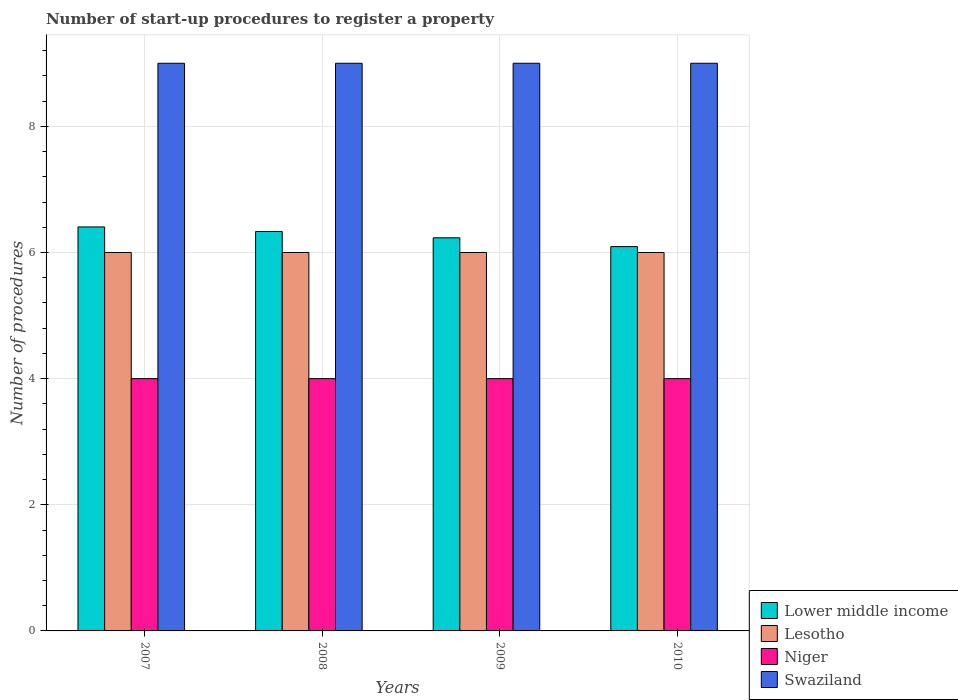How many different coloured bars are there?
Give a very brief answer. 4. Are the number of bars per tick equal to the number of legend labels?
Offer a very short reply. Yes. How many bars are there on the 1st tick from the right?
Offer a very short reply. 4. What is the label of the 2nd group of bars from the left?
Provide a short and direct response. 2008. Across all years, what is the maximum number of procedures required to register a property in Niger?
Make the answer very short. 4. Across all years, what is the minimum number of procedures required to register a property in Lesotho?
Provide a succinct answer. 6. In which year was the number of procedures required to register a property in Lower middle income maximum?
Provide a short and direct response. 2007. In which year was the number of procedures required to register a property in Niger minimum?
Your answer should be very brief. 2007. What is the total number of procedures required to register a property in Lower middle income in the graph?
Make the answer very short. 25.06. What is the difference between the number of procedures required to register a property in Lower middle income in 2008 and that in 2010?
Make the answer very short. 0.24. What is the difference between the number of procedures required to register a property in Niger in 2008 and the number of procedures required to register a property in Lower middle income in 2007?
Ensure brevity in your answer.  -2.4. What is the ratio of the number of procedures required to register a property in Lesotho in 2007 to that in 2008?
Keep it short and to the point. 1. Is the difference between the number of procedures required to register a property in Swaziland in 2008 and 2009 greater than the difference between the number of procedures required to register a property in Niger in 2008 and 2009?
Make the answer very short. No. What is the difference between the highest and the second highest number of procedures required to register a property in Lower middle income?
Offer a very short reply. 0.07. What is the difference between the highest and the lowest number of procedures required to register a property in Swaziland?
Offer a terse response. 0. In how many years, is the number of procedures required to register a property in Lesotho greater than the average number of procedures required to register a property in Lesotho taken over all years?
Offer a terse response. 0. Is it the case that in every year, the sum of the number of procedures required to register a property in Lower middle income and number of procedures required to register a property in Niger is greater than the sum of number of procedures required to register a property in Swaziland and number of procedures required to register a property in Lesotho?
Offer a terse response. Yes. What does the 4th bar from the left in 2009 represents?
Make the answer very short. Swaziland. What does the 3rd bar from the right in 2009 represents?
Your answer should be compact. Lesotho. How many bars are there?
Offer a very short reply. 16. Are the values on the major ticks of Y-axis written in scientific E-notation?
Your response must be concise. No. Where does the legend appear in the graph?
Your response must be concise. Bottom right. How are the legend labels stacked?
Your answer should be compact. Vertical. What is the title of the graph?
Your answer should be compact. Number of start-up procedures to register a property. What is the label or title of the X-axis?
Make the answer very short. Years. What is the label or title of the Y-axis?
Your answer should be compact. Number of procedures. What is the Number of procedures of Lower middle income in 2007?
Your response must be concise. 6.4. What is the Number of procedures in Lesotho in 2007?
Offer a very short reply. 6. What is the Number of procedures in Lower middle income in 2008?
Ensure brevity in your answer.  6.33. What is the Number of procedures in Niger in 2008?
Offer a terse response. 4. What is the Number of procedures of Swaziland in 2008?
Offer a very short reply. 9. What is the Number of procedures in Lower middle income in 2009?
Provide a succinct answer. 6.23. What is the Number of procedures of Niger in 2009?
Give a very brief answer. 4. What is the Number of procedures of Lower middle income in 2010?
Make the answer very short. 6.09. What is the Number of procedures of Niger in 2010?
Your answer should be very brief. 4. What is the Number of procedures of Swaziland in 2010?
Keep it short and to the point. 9. Across all years, what is the maximum Number of procedures of Lower middle income?
Your answer should be very brief. 6.4. Across all years, what is the maximum Number of procedures in Lesotho?
Keep it short and to the point. 6. Across all years, what is the minimum Number of procedures of Lower middle income?
Make the answer very short. 6.09. Across all years, what is the minimum Number of procedures in Lesotho?
Make the answer very short. 6. Across all years, what is the minimum Number of procedures of Niger?
Your answer should be compact. 4. What is the total Number of procedures of Lower middle income in the graph?
Your response must be concise. 25.06. What is the total Number of procedures in Lesotho in the graph?
Your answer should be compact. 24. What is the total Number of procedures of Niger in the graph?
Offer a very short reply. 16. What is the total Number of procedures of Swaziland in the graph?
Provide a short and direct response. 36. What is the difference between the Number of procedures of Lower middle income in 2007 and that in 2008?
Offer a very short reply. 0.07. What is the difference between the Number of procedures in Lesotho in 2007 and that in 2008?
Keep it short and to the point. 0. What is the difference between the Number of procedures in Swaziland in 2007 and that in 2008?
Offer a terse response. 0. What is the difference between the Number of procedures of Lower middle income in 2007 and that in 2009?
Provide a short and direct response. 0.17. What is the difference between the Number of procedures of Lower middle income in 2007 and that in 2010?
Offer a very short reply. 0.31. What is the difference between the Number of procedures in Lesotho in 2007 and that in 2010?
Provide a short and direct response. 0. What is the difference between the Number of procedures of Swaziland in 2007 and that in 2010?
Give a very brief answer. 0. What is the difference between the Number of procedures of Lower middle income in 2008 and that in 2009?
Offer a very short reply. 0.1. What is the difference between the Number of procedures of Lesotho in 2008 and that in 2009?
Keep it short and to the point. 0. What is the difference between the Number of procedures of Niger in 2008 and that in 2009?
Ensure brevity in your answer.  0. What is the difference between the Number of procedures in Lower middle income in 2008 and that in 2010?
Your response must be concise. 0.24. What is the difference between the Number of procedures of Lesotho in 2008 and that in 2010?
Give a very brief answer. 0. What is the difference between the Number of procedures in Niger in 2008 and that in 2010?
Make the answer very short. 0. What is the difference between the Number of procedures of Swaziland in 2008 and that in 2010?
Your answer should be compact. 0. What is the difference between the Number of procedures in Lower middle income in 2009 and that in 2010?
Your answer should be compact. 0.14. What is the difference between the Number of procedures in Lesotho in 2009 and that in 2010?
Provide a short and direct response. 0. What is the difference between the Number of procedures of Niger in 2009 and that in 2010?
Your response must be concise. 0. What is the difference between the Number of procedures in Lower middle income in 2007 and the Number of procedures in Lesotho in 2008?
Offer a very short reply. 0.4. What is the difference between the Number of procedures of Lower middle income in 2007 and the Number of procedures of Niger in 2008?
Ensure brevity in your answer.  2.4. What is the difference between the Number of procedures in Lower middle income in 2007 and the Number of procedures in Swaziland in 2008?
Ensure brevity in your answer.  -2.6. What is the difference between the Number of procedures of Lesotho in 2007 and the Number of procedures of Swaziland in 2008?
Offer a very short reply. -3. What is the difference between the Number of procedures of Lower middle income in 2007 and the Number of procedures of Lesotho in 2009?
Provide a short and direct response. 0.4. What is the difference between the Number of procedures in Lower middle income in 2007 and the Number of procedures in Niger in 2009?
Provide a succinct answer. 2.4. What is the difference between the Number of procedures of Lower middle income in 2007 and the Number of procedures of Swaziland in 2009?
Make the answer very short. -2.6. What is the difference between the Number of procedures in Lesotho in 2007 and the Number of procedures in Niger in 2009?
Your answer should be very brief. 2. What is the difference between the Number of procedures in Niger in 2007 and the Number of procedures in Swaziland in 2009?
Make the answer very short. -5. What is the difference between the Number of procedures of Lower middle income in 2007 and the Number of procedures of Lesotho in 2010?
Make the answer very short. 0.4. What is the difference between the Number of procedures in Lower middle income in 2007 and the Number of procedures in Niger in 2010?
Your answer should be very brief. 2.4. What is the difference between the Number of procedures in Lower middle income in 2007 and the Number of procedures in Swaziland in 2010?
Offer a very short reply. -2.6. What is the difference between the Number of procedures in Niger in 2007 and the Number of procedures in Swaziland in 2010?
Give a very brief answer. -5. What is the difference between the Number of procedures in Lower middle income in 2008 and the Number of procedures in Lesotho in 2009?
Your response must be concise. 0.33. What is the difference between the Number of procedures in Lower middle income in 2008 and the Number of procedures in Niger in 2009?
Ensure brevity in your answer.  2.33. What is the difference between the Number of procedures of Lower middle income in 2008 and the Number of procedures of Swaziland in 2009?
Your answer should be very brief. -2.67. What is the difference between the Number of procedures of Lesotho in 2008 and the Number of procedures of Niger in 2009?
Give a very brief answer. 2. What is the difference between the Number of procedures in Niger in 2008 and the Number of procedures in Swaziland in 2009?
Make the answer very short. -5. What is the difference between the Number of procedures in Lower middle income in 2008 and the Number of procedures in Niger in 2010?
Keep it short and to the point. 2.33. What is the difference between the Number of procedures of Lower middle income in 2008 and the Number of procedures of Swaziland in 2010?
Offer a terse response. -2.67. What is the difference between the Number of procedures in Lesotho in 2008 and the Number of procedures in Swaziland in 2010?
Give a very brief answer. -3. What is the difference between the Number of procedures in Niger in 2008 and the Number of procedures in Swaziland in 2010?
Offer a very short reply. -5. What is the difference between the Number of procedures of Lower middle income in 2009 and the Number of procedures of Lesotho in 2010?
Your response must be concise. 0.23. What is the difference between the Number of procedures of Lower middle income in 2009 and the Number of procedures of Niger in 2010?
Offer a very short reply. 2.23. What is the difference between the Number of procedures in Lower middle income in 2009 and the Number of procedures in Swaziland in 2010?
Provide a short and direct response. -2.77. What is the average Number of procedures in Lower middle income per year?
Your answer should be compact. 6.27. What is the average Number of procedures in Lesotho per year?
Give a very brief answer. 6. What is the average Number of procedures of Swaziland per year?
Offer a terse response. 9. In the year 2007, what is the difference between the Number of procedures of Lower middle income and Number of procedures of Lesotho?
Your response must be concise. 0.4. In the year 2007, what is the difference between the Number of procedures in Lower middle income and Number of procedures in Niger?
Keep it short and to the point. 2.4. In the year 2007, what is the difference between the Number of procedures in Lower middle income and Number of procedures in Swaziland?
Your response must be concise. -2.6. In the year 2007, what is the difference between the Number of procedures in Niger and Number of procedures in Swaziland?
Provide a short and direct response. -5. In the year 2008, what is the difference between the Number of procedures in Lower middle income and Number of procedures in Lesotho?
Make the answer very short. 0.33. In the year 2008, what is the difference between the Number of procedures in Lower middle income and Number of procedures in Niger?
Offer a terse response. 2.33. In the year 2008, what is the difference between the Number of procedures in Lower middle income and Number of procedures in Swaziland?
Give a very brief answer. -2.67. In the year 2008, what is the difference between the Number of procedures of Lesotho and Number of procedures of Swaziland?
Give a very brief answer. -3. In the year 2009, what is the difference between the Number of procedures of Lower middle income and Number of procedures of Lesotho?
Keep it short and to the point. 0.23. In the year 2009, what is the difference between the Number of procedures in Lower middle income and Number of procedures in Niger?
Your response must be concise. 2.23. In the year 2009, what is the difference between the Number of procedures in Lower middle income and Number of procedures in Swaziland?
Give a very brief answer. -2.77. In the year 2009, what is the difference between the Number of procedures of Niger and Number of procedures of Swaziland?
Give a very brief answer. -5. In the year 2010, what is the difference between the Number of procedures in Lower middle income and Number of procedures in Lesotho?
Your response must be concise. 0.09. In the year 2010, what is the difference between the Number of procedures of Lower middle income and Number of procedures of Niger?
Your answer should be compact. 2.09. In the year 2010, what is the difference between the Number of procedures of Lower middle income and Number of procedures of Swaziland?
Offer a very short reply. -2.91. In the year 2010, what is the difference between the Number of procedures of Lesotho and Number of procedures of Niger?
Your answer should be compact. 2. In the year 2010, what is the difference between the Number of procedures in Niger and Number of procedures in Swaziland?
Your response must be concise. -5. What is the ratio of the Number of procedures in Lower middle income in 2007 to that in 2008?
Give a very brief answer. 1.01. What is the ratio of the Number of procedures of Lesotho in 2007 to that in 2008?
Provide a succinct answer. 1. What is the ratio of the Number of procedures of Swaziland in 2007 to that in 2008?
Offer a very short reply. 1. What is the ratio of the Number of procedures of Lower middle income in 2007 to that in 2009?
Make the answer very short. 1.03. What is the ratio of the Number of procedures of Lesotho in 2007 to that in 2009?
Ensure brevity in your answer.  1. What is the ratio of the Number of procedures in Swaziland in 2007 to that in 2009?
Offer a terse response. 1. What is the ratio of the Number of procedures of Lower middle income in 2007 to that in 2010?
Your answer should be compact. 1.05. What is the ratio of the Number of procedures in Lower middle income in 2008 to that in 2009?
Provide a succinct answer. 1.02. What is the ratio of the Number of procedures of Lesotho in 2008 to that in 2009?
Make the answer very short. 1. What is the ratio of the Number of procedures in Swaziland in 2008 to that in 2009?
Give a very brief answer. 1. What is the ratio of the Number of procedures in Lower middle income in 2008 to that in 2010?
Your answer should be very brief. 1.04. What is the ratio of the Number of procedures of Lesotho in 2008 to that in 2010?
Your answer should be very brief. 1. What is the ratio of the Number of procedures of Lower middle income in 2009 to that in 2010?
Give a very brief answer. 1.02. What is the ratio of the Number of procedures of Lesotho in 2009 to that in 2010?
Your response must be concise. 1. What is the ratio of the Number of procedures in Niger in 2009 to that in 2010?
Your response must be concise. 1. What is the ratio of the Number of procedures of Swaziland in 2009 to that in 2010?
Offer a terse response. 1. What is the difference between the highest and the second highest Number of procedures in Lower middle income?
Keep it short and to the point. 0.07. What is the difference between the highest and the second highest Number of procedures of Lesotho?
Ensure brevity in your answer.  0. What is the difference between the highest and the second highest Number of procedures of Niger?
Provide a short and direct response. 0. What is the difference between the highest and the second highest Number of procedures in Swaziland?
Keep it short and to the point. 0. What is the difference between the highest and the lowest Number of procedures of Lower middle income?
Your answer should be very brief. 0.31. What is the difference between the highest and the lowest Number of procedures in Niger?
Provide a short and direct response. 0. 